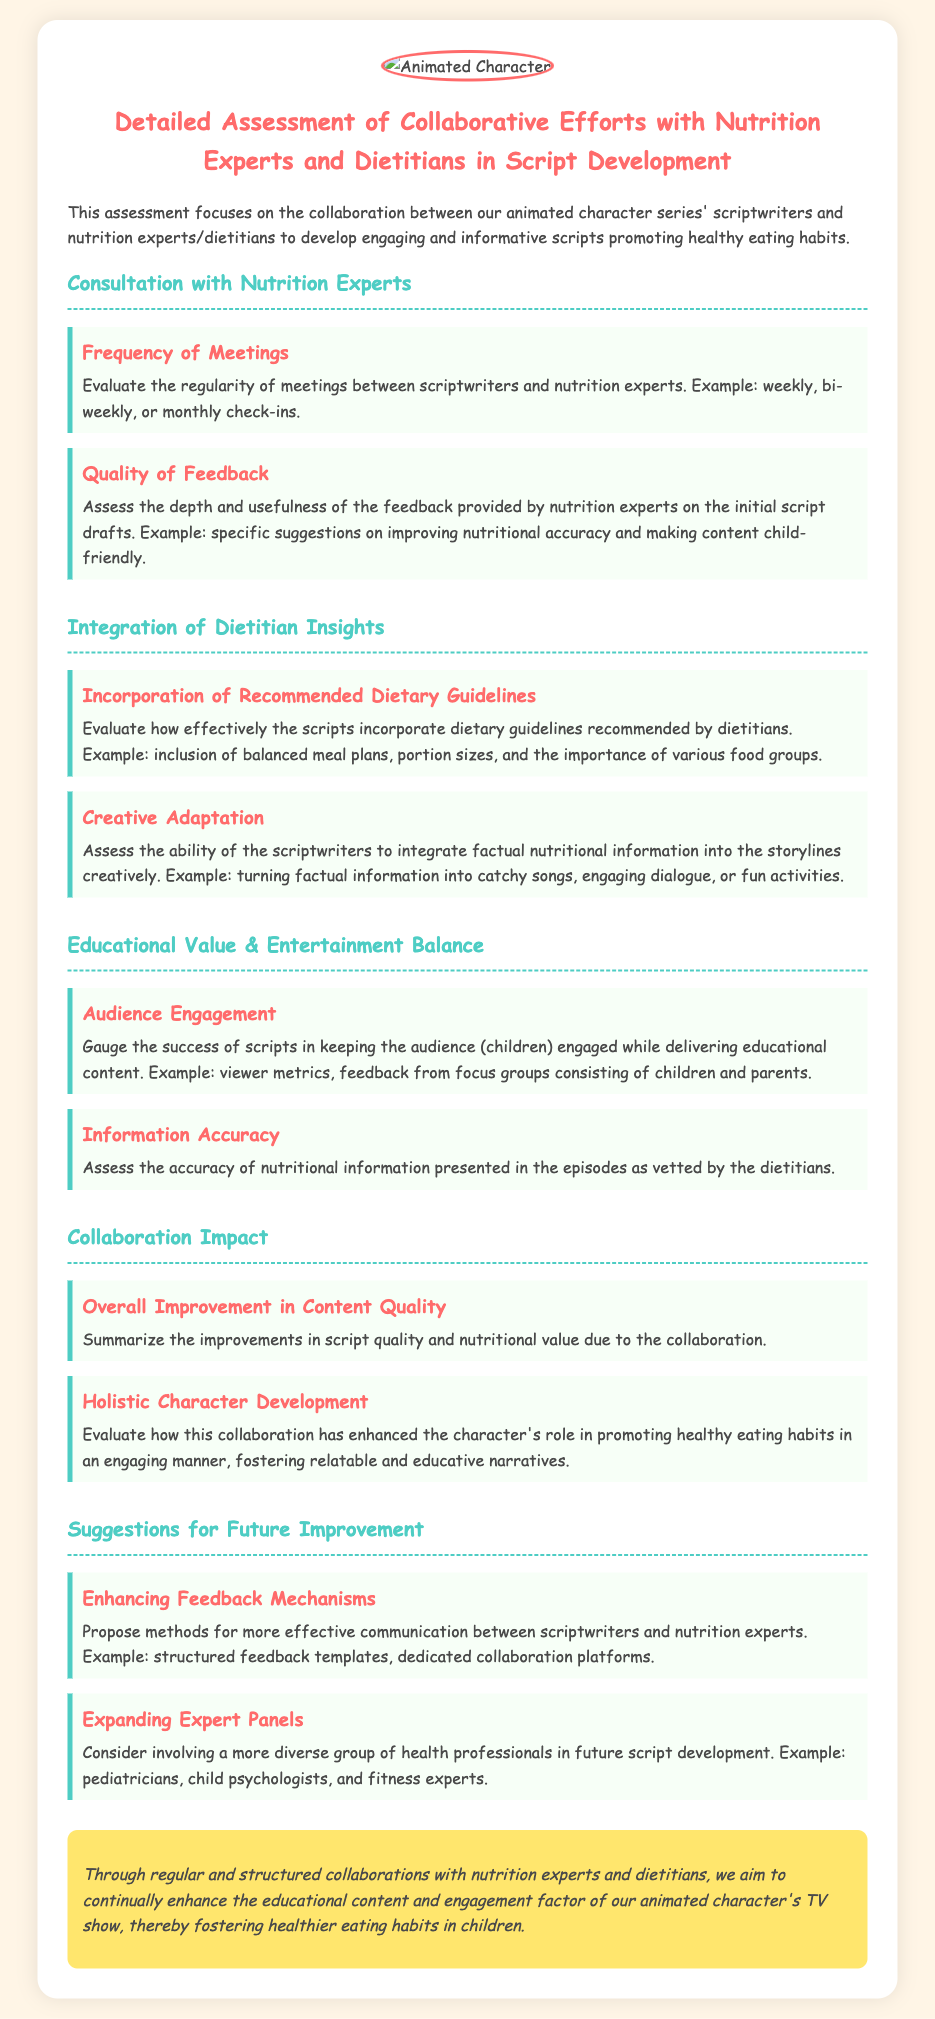What is the title of the assessment? The title of the assessment is provided at the beginning of the document, emphasizing the focus of the assessment.
Answer: Detailed Assessment of Collaborative Efforts with Nutrition Experts and Dietitians in Script Development What is one method suggested for enhancing feedback mechanisms? The document mentions a specific method under the suggestions for future improvement section.
Answer: Structured feedback templates How often are meetings suggested between scriptwriters and nutrition experts? The document discusses the regularity of meetings, providing different frequency options as examples.
Answer: Weekly, bi-weekly, or monthly What aspect of scripts is evaluated for audience engagement? The document discusses the success of scripts in a particular area related to keeping the audience engaged.
Answer: Viewer metrics Which section mentions the incorporation of dietary guidelines? The document organizes information into sections, and this particular aspect is covered in a specified section.
Answer: Integration of Dietitian Insights How is the balance of educational value and entertainment assessed? The document outlines the criteria used to gauge this balance, indicating a focus on audience engagement and information accuracy.
Answer: Audience engagement, Information accuracy 